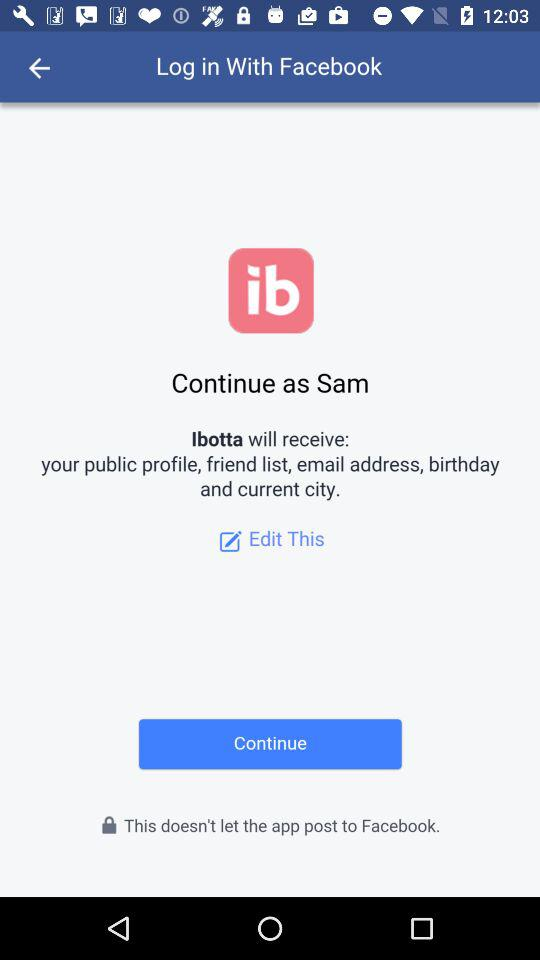What is the user name? The user name is Sam. 